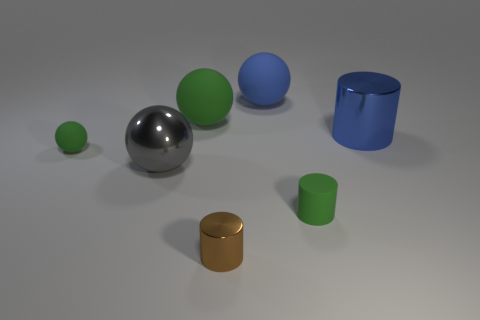There is a big blue object left of the shiny cylinder on the right side of the tiny thing on the right side of the tiny brown shiny object; what is its material?
Ensure brevity in your answer.  Rubber. Are there any shiny things to the right of the big shiny cylinder?
Offer a very short reply. No. There is a green object that is the same size as the gray ball; what is its shape?
Offer a very short reply. Sphere. Is the gray thing made of the same material as the large blue cylinder?
Your answer should be very brief. Yes. How many metal things are tiny cyan cylinders or brown cylinders?
Keep it short and to the point. 1. The tiny rubber thing that is the same color as the tiny rubber ball is what shape?
Offer a very short reply. Cylinder. Is the color of the tiny rubber thing in front of the small green ball the same as the tiny sphere?
Your answer should be very brief. Yes. There is a matte thing behind the big matte thing that is in front of the blue rubber sphere; what is its shape?
Offer a very short reply. Sphere. What number of objects are either big spheres to the right of the gray shiny object or metal cylinders to the right of the tiny matte cylinder?
Make the answer very short. 3. There is a large gray thing that is made of the same material as the big blue cylinder; what is its shape?
Provide a succinct answer. Sphere. 